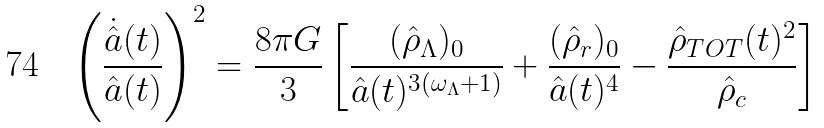<formula> <loc_0><loc_0><loc_500><loc_500>\left ( \frac { \dot { \hat { a } } ( t ) } { \hat { a } ( t ) } \right ) ^ { 2 } = \frac { 8 \pi G } { 3 } \left [ \frac { ( \hat { \rho } _ { \Lambda } ) _ { 0 } } { \hat { a } ( t ) ^ { 3 ( \omega _ { \Lambda } + 1 ) } } + \frac { ( \hat { \rho } _ { r } ) _ { 0 } } { \hat { a } ( t ) ^ { 4 } } - \frac { \hat { \rho } _ { T O T } ( t ) ^ { 2 } } { \hat { \rho } _ { c } } \right ]</formula> 